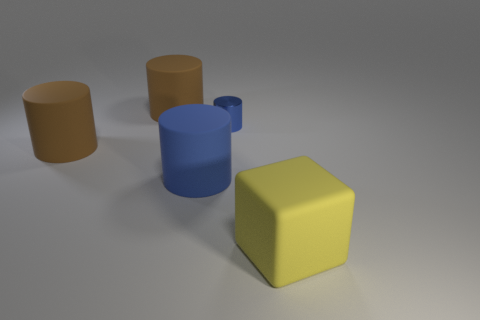Subtract all brown blocks. How many blue cylinders are left? 2 Subtract all large cylinders. How many cylinders are left? 1 Subtract all cyan cylinders. Subtract all red cubes. How many cylinders are left? 4 Add 2 small gray cylinders. How many objects exist? 7 Add 1 brown matte cylinders. How many brown matte cylinders exist? 3 Subtract 1 blue cylinders. How many objects are left? 4 Subtract all cylinders. How many objects are left? 1 Subtract all large purple cubes. Subtract all big brown cylinders. How many objects are left? 3 Add 4 large brown rubber cylinders. How many large brown rubber cylinders are left? 6 